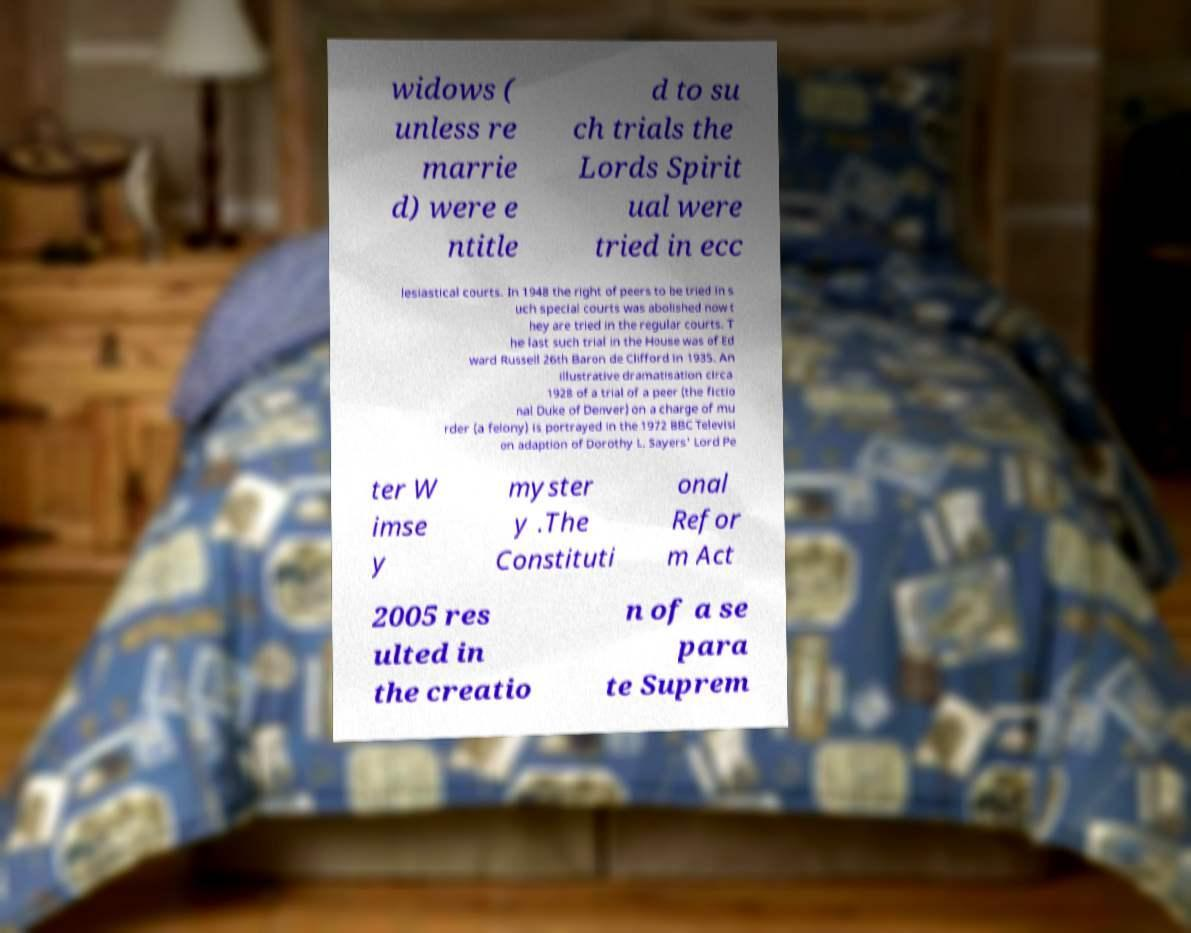Please read and relay the text visible in this image. What does it say? widows ( unless re marrie d) were e ntitle d to su ch trials the Lords Spirit ual were tried in ecc lesiastical courts. In 1948 the right of peers to be tried in s uch special courts was abolished now t hey are tried in the regular courts. T he last such trial in the House was of Ed ward Russell 26th Baron de Clifford in 1935. An illustrative dramatisation circa 1928 of a trial of a peer (the fictio nal Duke of Denver) on a charge of mu rder (a felony) is portrayed in the 1972 BBC Televisi on adaption of Dorothy L. Sayers' Lord Pe ter W imse y myster y .The Constituti onal Refor m Act 2005 res ulted in the creatio n of a se para te Suprem 